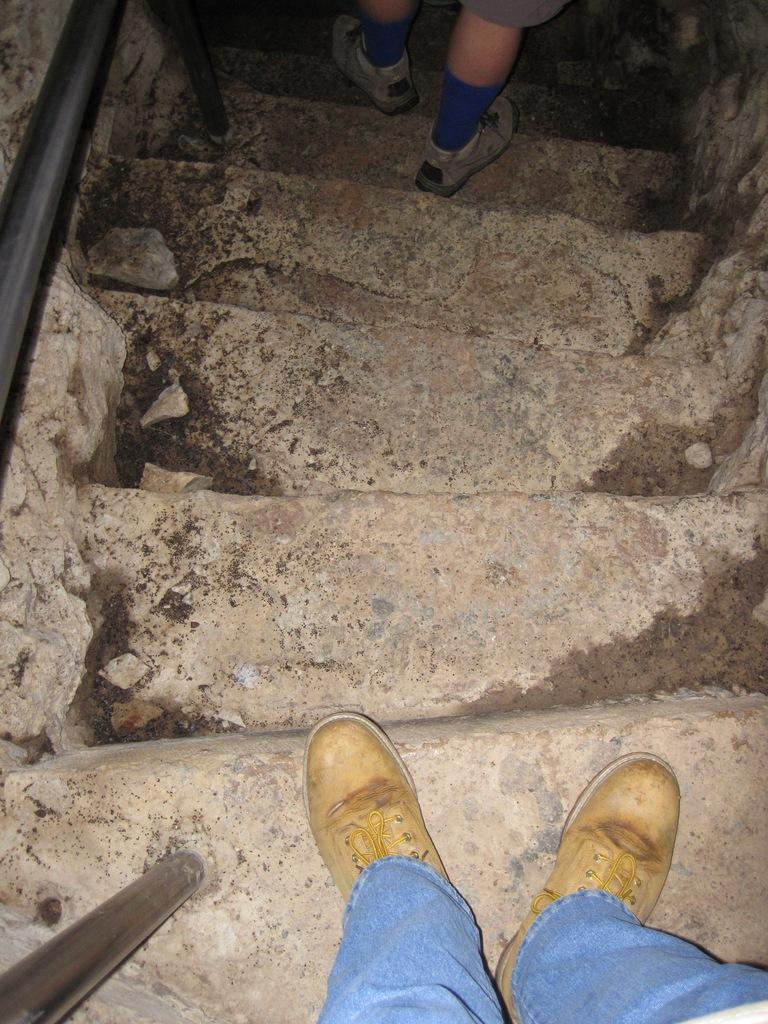What can be seen in the image that people use to move between different levels? There are steps in the image that people use to move between different levels. Can you describe the actions of the people in the image? Two men are walking on the steps in the image. What is located on the left side of the image? There is a rod on the left side of the image. What route are the men taking to reach the top of the steps in the image? The image does not provide information about the route the men are taking to reach the top of the steps. 